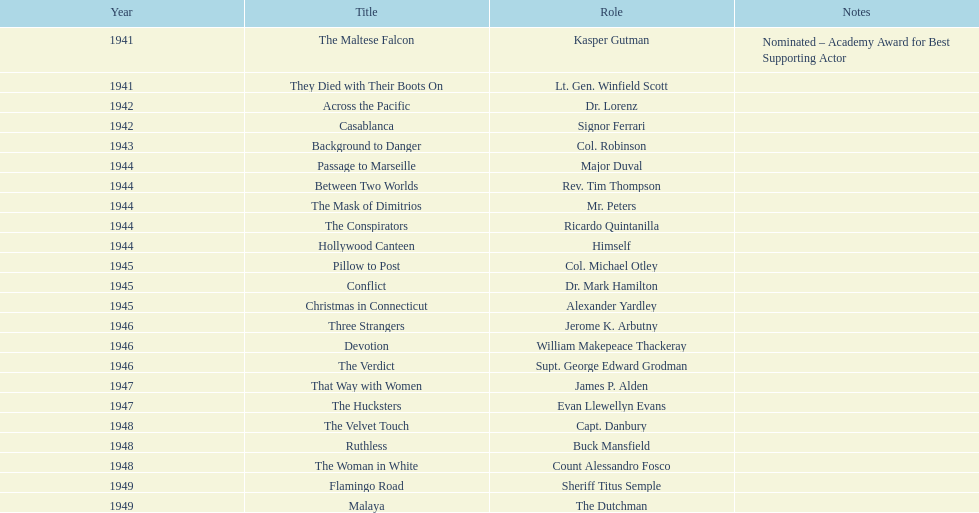How many cinematic works has he participated in from 1941 to 1949? 23. 